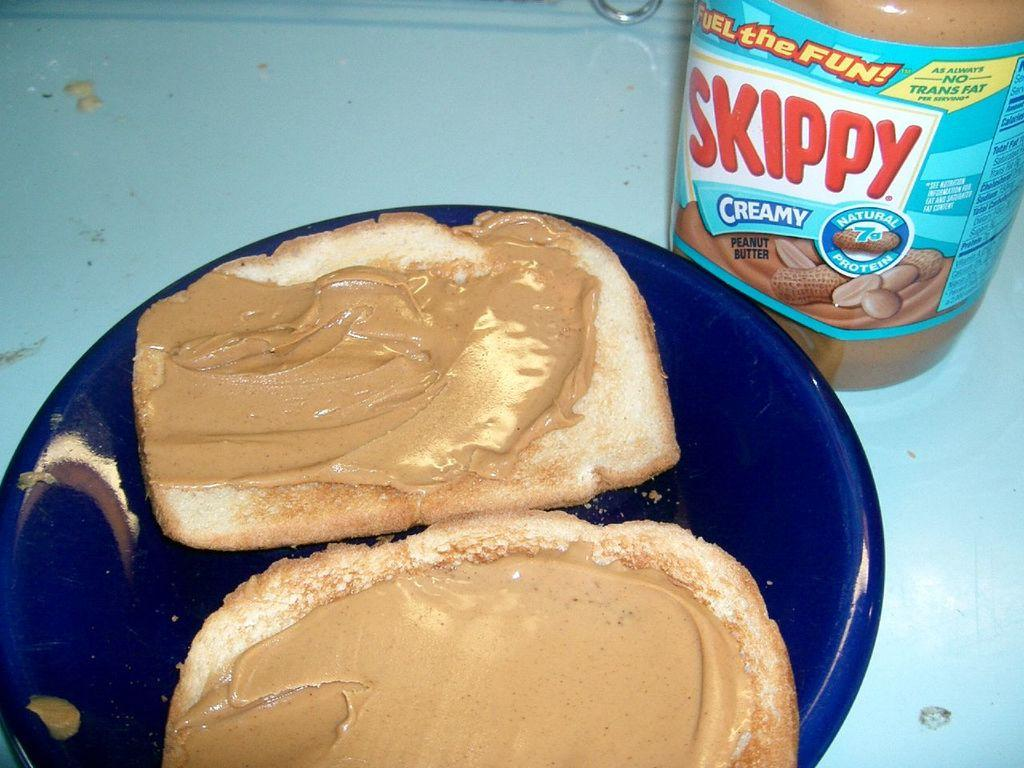What piece of furniture is present in the image? There is a table in the image. What object can be seen on the table? There is a bottle on the table. What type of food is visible on the table? There are bread slices with peanut butter on a plate on the table. How many ants are crawling on the money in the image? There is no money or ants present in the image. 